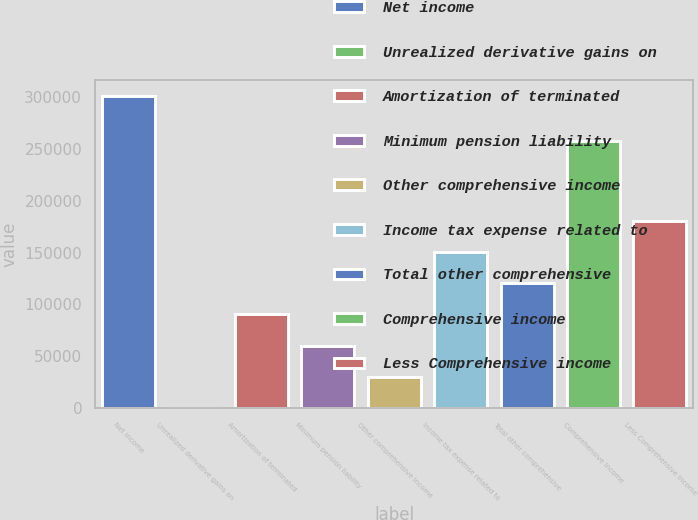Convert chart. <chart><loc_0><loc_0><loc_500><loc_500><bar_chart><fcel>Net income<fcel>Unrealized derivative gains on<fcel>Amortization of terminated<fcel>Minimum pension liability<fcel>Other comprehensive income<fcel>Income tax expense related to<fcel>Total other comprehensive<fcel>Comprehensive income<fcel>Less Comprehensive income<nl><fcel>300970<fcel>1.23<fcel>90291.9<fcel>60195<fcel>30098.1<fcel>150486<fcel>120389<fcel>257680<fcel>180583<nl></chart> 